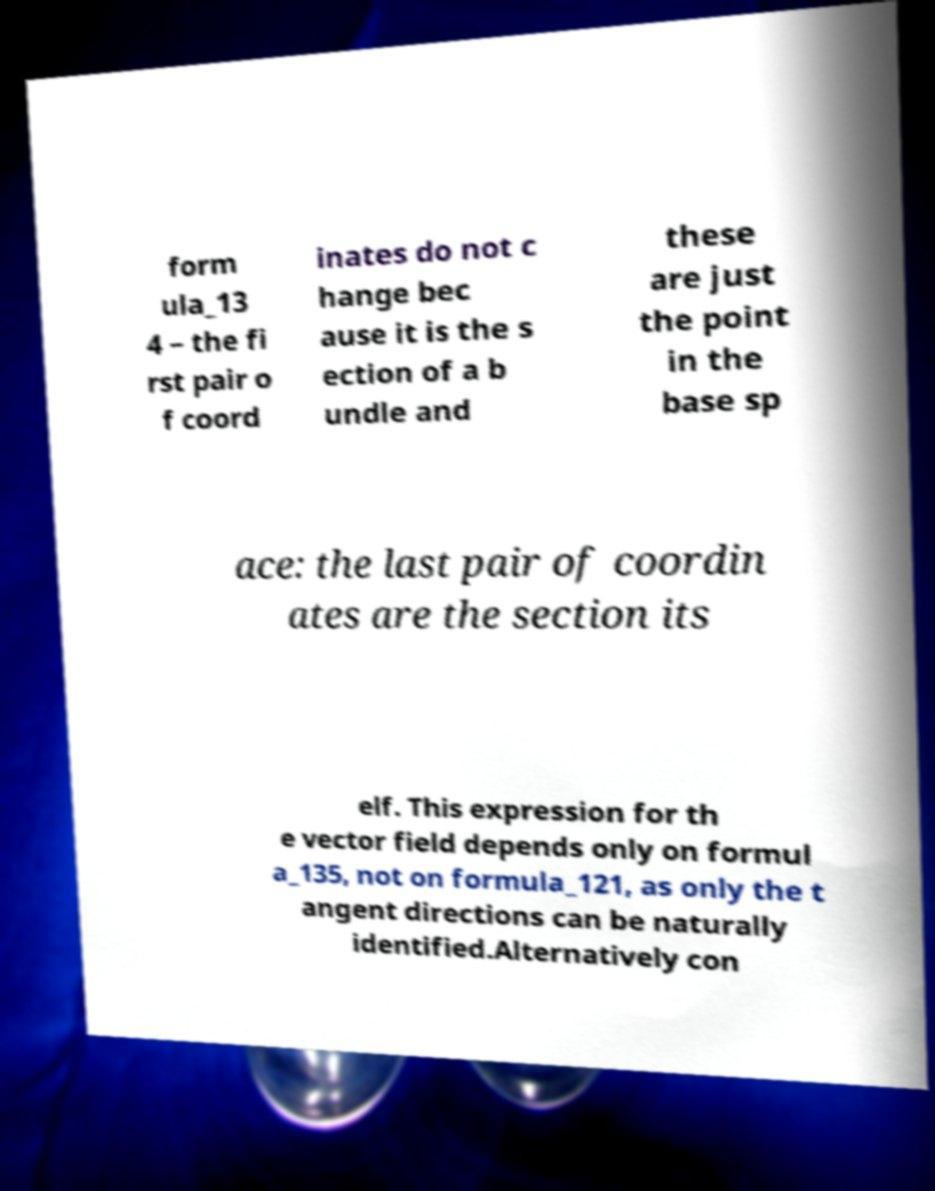There's text embedded in this image that I need extracted. Can you transcribe it verbatim? form ula_13 4 – the fi rst pair o f coord inates do not c hange bec ause it is the s ection of a b undle and these are just the point in the base sp ace: the last pair of coordin ates are the section its elf. This expression for th e vector field depends only on formul a_135, not on formula_121, as only the t angent directions can be naturally identified.Alternatively con 